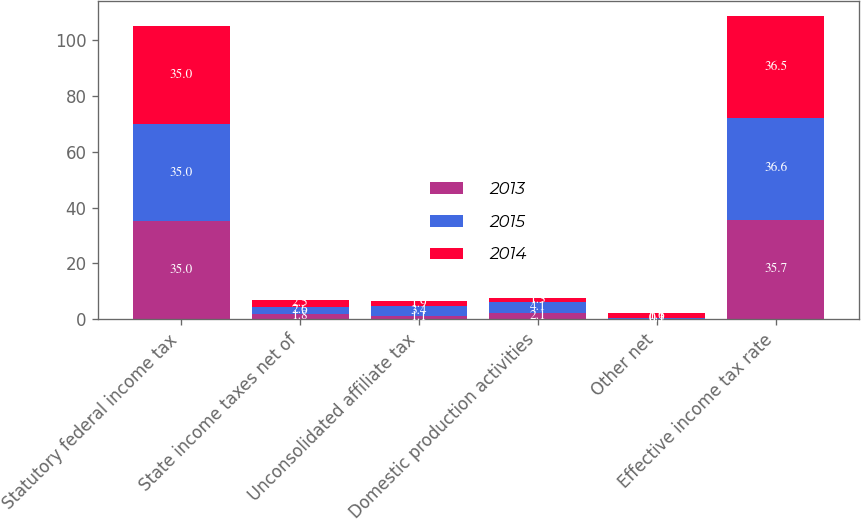Convert chart. <chart><loc_0><loc_0><loc_500><loc_500><stacked_bar_chart><ecel><fcel>Statutory federal income tax<fcel>State income taxes net of<fcel>Unconsolidated affiliate tax<fcel>Domestic production activities<fcel>Other net<fcel>Effective income tax rate<nl><fcel>2013<fcel>35<fcel>1.8<fcel>1.1<fcel>2.1<fcel>0.1<fcel>35.7<nl><fcel>2015<fcel>35<fcel>2.6<fcel>3.4<fcel>4.1<fcel>0.3<fcel>36.6<nl><fcel>2014<fcel>35<fcel>2.5<fcel>1.9<fcel>1.3<fcel>1.6<fcel>36.5<nl></chart> 